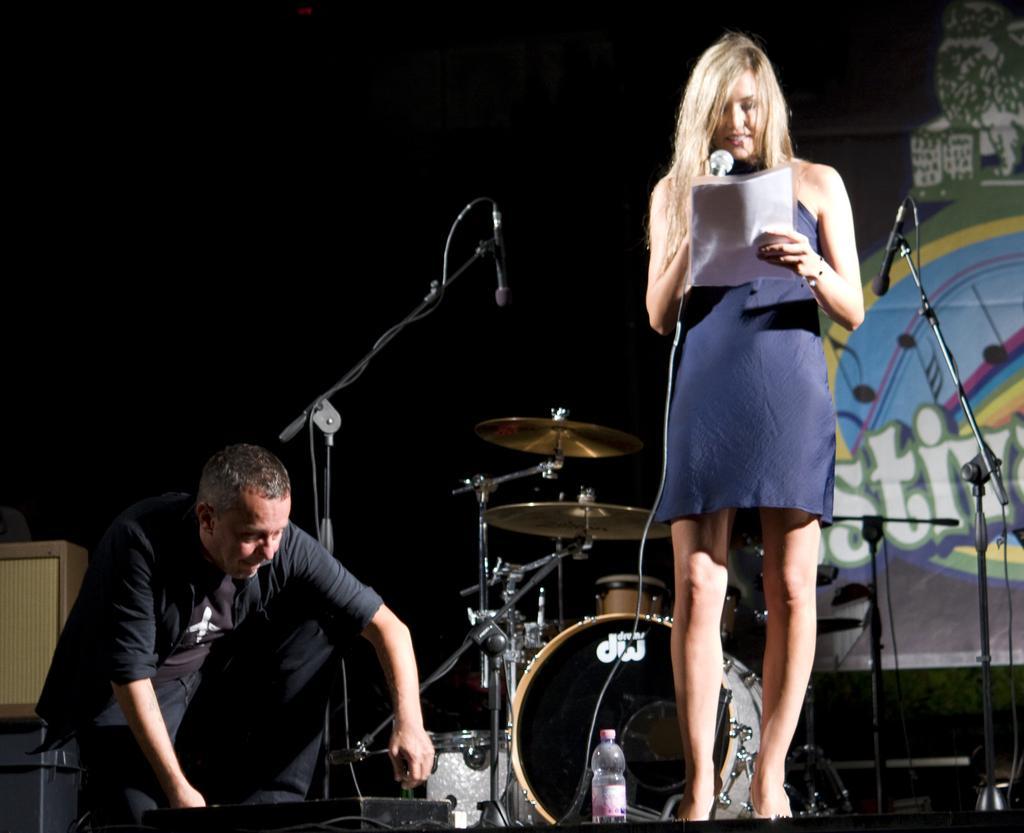Could you give a brief overview of what you see in this image? This image is taken indoors. In the background there is a wall with a painting. At the bottom of the image there is dais. On the left side of the image there is a man. In the middle of the image a woman is standing on the dais and she is holding a mic and a paper in her hands and there are a few musical instruments and a mic on the dais. 